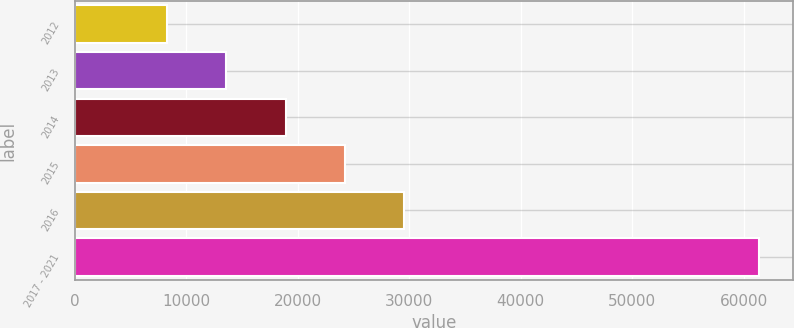Convert chart. <chart><loc_0><loc_0><loc_500><loc_500><bar_chart><fcel>2012<fcel>2013<fcel>2014<fcel>2015<fcel>2016<fcel>2017 - 2021<nl><fcel>8288<fcel>13593.8<fcel>18899.6<fcel>24205.4<fcel>29511.2<fcel>61346<nl></chart> 